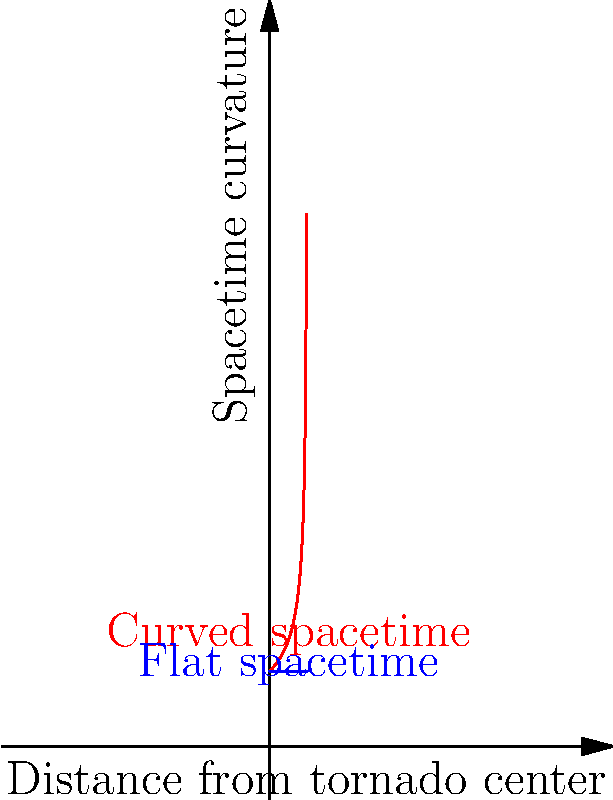Consider the curvature of spacetime near a massive tornado. If the graph shows the spacetime curvature (vertical axis) as a function of distance from the tornado's center (horizontal axis), what mathematical function best describes the red curve representing the curved spacetime?

A) $f(x) = \frac{1}{\sqrt{1-2x}}$
B) $f(x) = \frac{1}{1-2x}$
C) $f(x) = \sqrt{1-2x}$
D) $f(x) = 1-2x$ To answer this question, let's analyze the graph and the concept of spacetime curvature:

1. The blue line represents flat spacetime, which has a constant curvature of 1.

2. The red curve shows how spacetime becomes more curved as we approach the tornado's center (x approaches 0).

3. In general relativity, the curvature of spacetime near massive objects is often described by the Schwarzschild metric, which has a similar form to the function $\frac{1}{\sqrt{1-2x}}$.

4. Looking at the options:
   A) $f(x) = \frac{1}{\sqrt{1-2x}}$ matches the shape of the curve and the concept of increasing curvature as x approaches 0.5.
   B) $f(x) = \frac{1}{1-2x}$ would have a vertical asymptote at x = 0.5, which is not shown in the graph.
   C) $f(x) = \sqrt{1-2x}$ would curve downward, opposite to what we see.
   D) $f(x) = 1-2x$ would be a straight line, which doesn't match the curve.

5. Therefore, the function that best describes the red curve is $f(x) = \frac{1}{\sqrt{1-2x}}$.

This function represents how spacetime becomes more curved (larger y-values) as we get closer to the tornado's center (x approaching 0.5), similar to how spacetime curves near massive objects like black holes or, in this case, an extremely powerful tornado.
Answer: A) $f(x) = \frac{1}{\sqrt{1-2x}}$ 